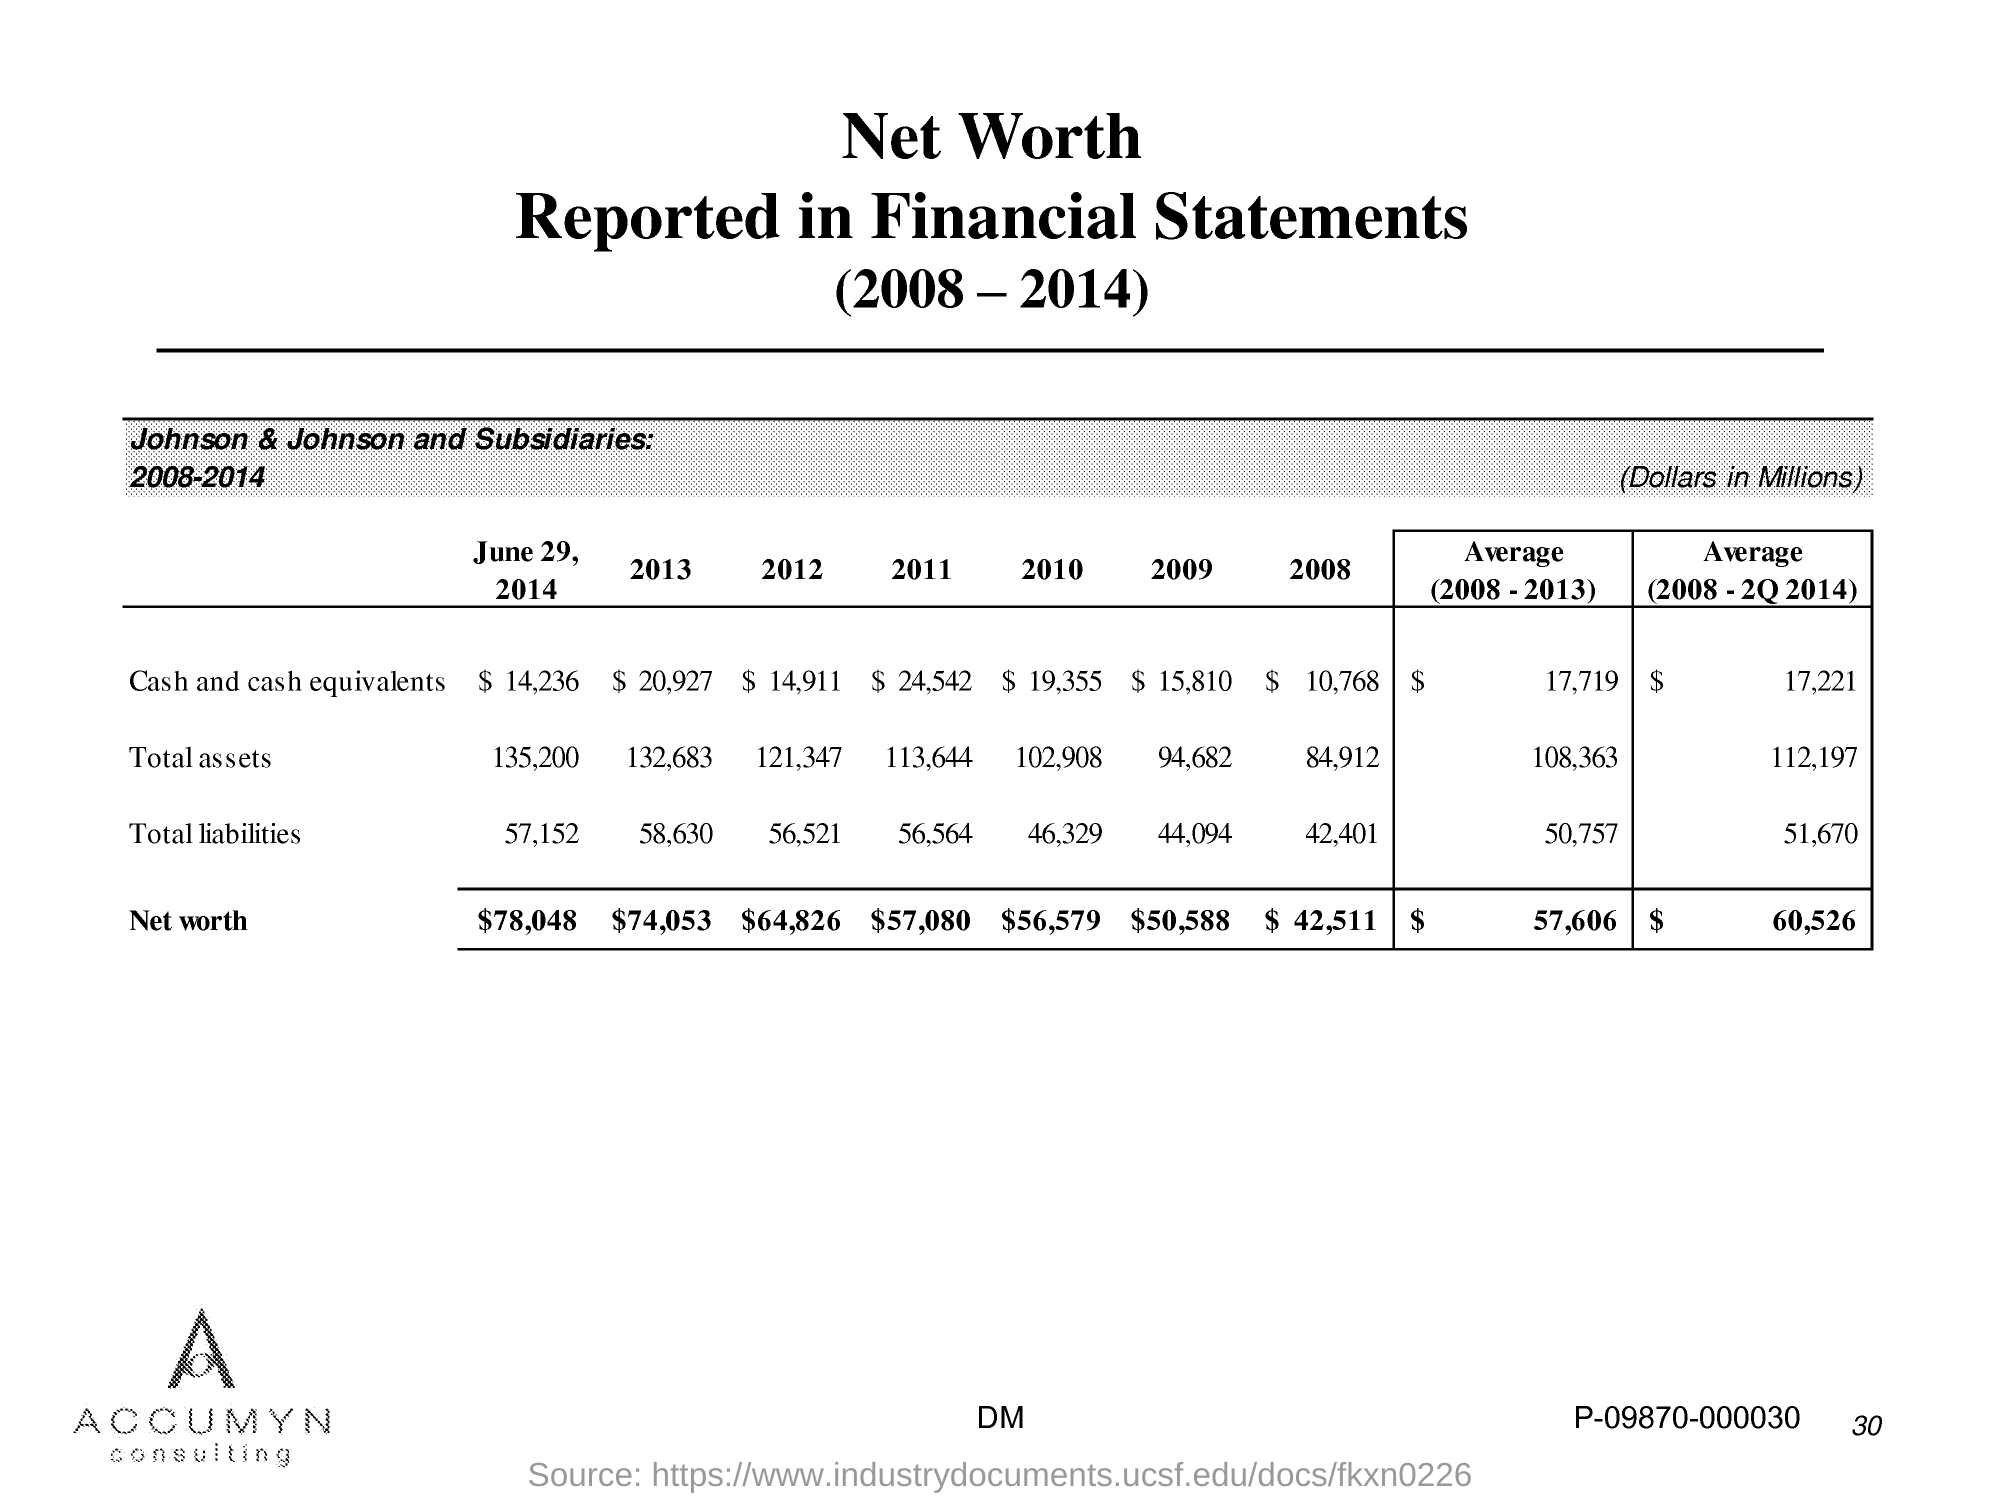what is the total assets in 2011? In 2011, Johnson & Johnson and its subsidiaries reported total assets of $113,644 million, as indicated in the financial statement extract. 